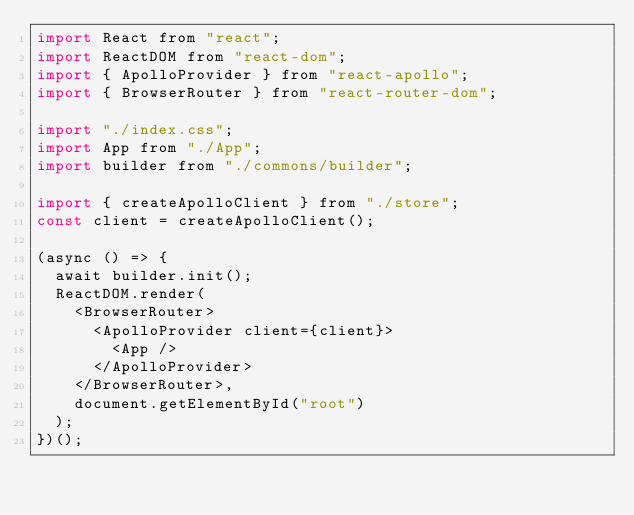Convert code to text. <code><loc_0><loc_0><loc_500><loc_500><_JavaScript_>import React from "react";
import ReactDOM from "react-dom";
import { ApolloProvider } from "react-apollo";
import { BrowserRouter } from "react-router-dom";

import "./index.css";
import App from "./App";
import builder from "./commons/builder";

import { createApolloClient } from "./store";
const client = createApolloClient();

(async () => {
  await builder.init();
  ReactDOM.render(
    <BrowserRouter>
      <ApolloProvider client={client}>
        <App />
      </ApolloProvider>
    </BrowserRouter>,
    document.getElementById("root")
  );
})();
</code> 